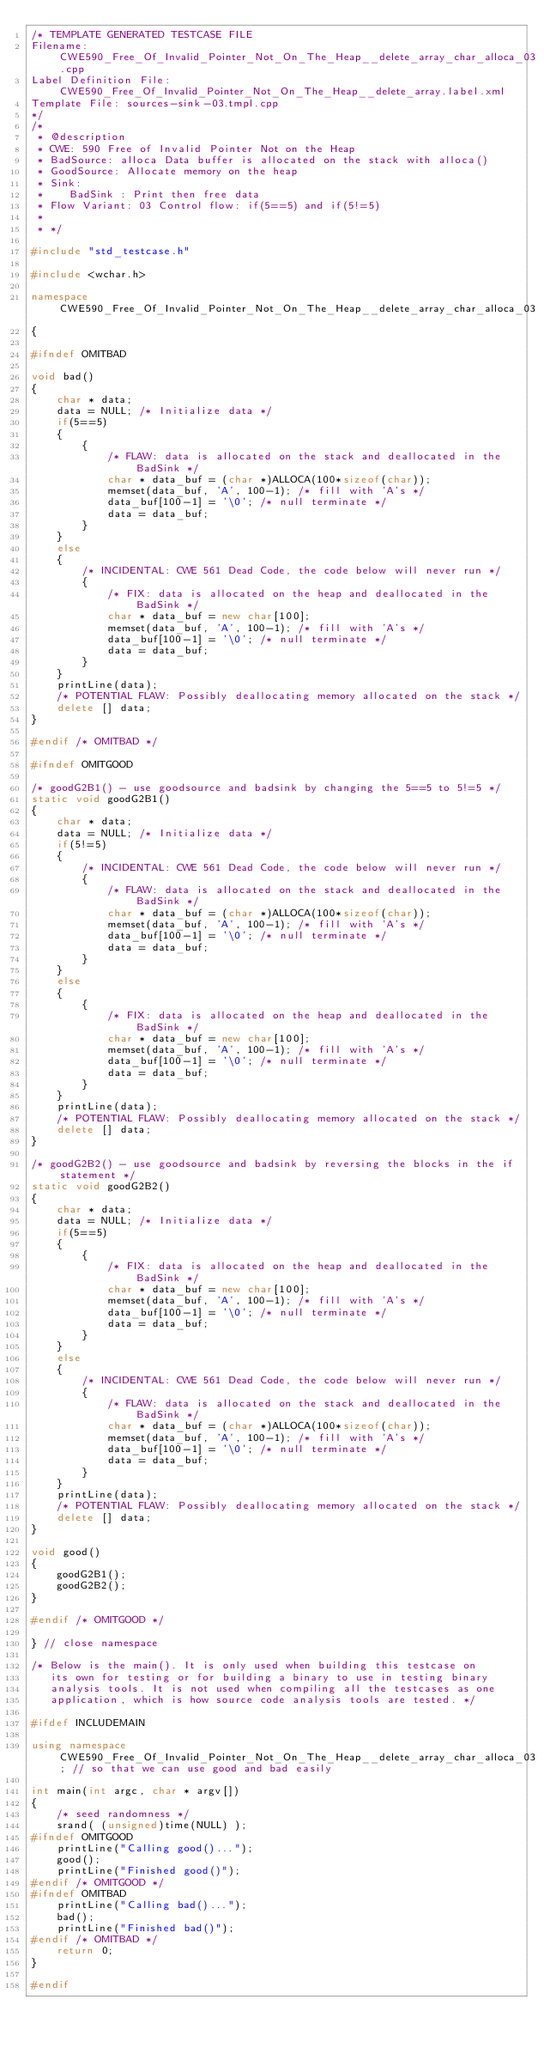Convert code to text. <code><loc_0><loc_0><loc_500><loc_500><_C++_>/* TEMPLATE GENERATED TESTCASE FILE
Filename: CWE590_Free_Of_Invalid_Pointer_Not_On_The_Heap__delete_array_char_alloca_03.cpp
Label Definition File: CWE590_Free_Of_Invalid_Pointer_Not_On_The_Heap__delete_array.label.xml
Template File: sources-sink-03.tmpl.cpp
*/
/*
 * @description
 * CWE: 590 Free of Invalid Pointer Not on the Heap
 * BadSource: alloca Data buffer is allocated on the stack with alloca()
 * GoodSource: Allocate memory on the heap
 * Sink:
 *    BadSink : Print then free data
 * Flow Variant: 03 Control flow: if(5==5) and if(5!=5)
 *
 * */

#include "std_testcase.h"

#include <wchar.h>

namespace CWE590_Free_Of_Invalid_Pointer_Not_On_The_Heap__delete_array_char_alloca_03
{

#ifndef OMITBAD

void bad()
{
    char * data;
    data = NULL; /* Initialize data */
    if(5==5)
    {
        {
            /* FLAW: data is allocated on the stack and deallocated in the BadSink */
            char * data_buf = (char *)ALLOCA(100*sizeof(char));
            memset(data_buf, 'A', 100-1); /* fill with 'A's */
            data_buf[100-1] = '\0'; /* null terminate */
            data = data_buf;
        }
    }
    else
    {
        /* INCIDENTAL: CWE 561 Dead Code, the code below will never run */
        {
            /* FIX: data is allocated on the heap and deallocated in the BadSink */
            char * data_buf = new char[100];
            memset(data_buf, 'A', 100-1); /* fill with 'A's */
            data_buf[100-1] = '\0'; /* null terminate */
            data = data_buf;
        }
    }
    printLine(data);
    /* POTENTIAL FLAW: Possibly deallocating memory allocated on the stack */
    delete [] data;
}

#endif /* OMITBAD */

#ifndef OMITGOOD

/* goodG2B1() - use goodsource and badsink by changing the 5==5 to 5!=5 */
static void goodG2B1()
{
    char * data;
    data = NULL; /* Initialize data */
    if(5!=5)
    {
        /* INCIDENTAL: CWE 561 Dead Code, the code below will never run */
        {
            /* FLAW: data is allocated on the stack and deallocated in the BadSink */
            char * data_buf = (char *)ALLOCA(100*sizeof(char));
            memset(data_buf, 'A', 100-1); /* fill with 'A's */
            data_buf[100-1] = '\0'; /* null terminate */
            data = data_buf;
        }
    }
    else
    {
        {
            /* FIX: data is allocated on the heap and deallocated in the BadSink */
            char * data_buf = new char[100];
            memset(data_buf, 'A', 100-1); /* fill with 'A's */
            data_buf[100-1] = '\0'; /* null terminate */
            data = data_buf;
        }
    }
    printLine(data);
    /* POTENTIAL FLAW: Possibly deallocating memory allocated on the stack */
    delete [] data;
}

/* goodG2B2() - use goodsource and badsink by reversing the blocks in the if statement */
static void goodG2B2()
{
    char * data;
    data = NULL; /* Initialize data */
    if(5==5)
    {
        {
            /* FIX: data is allocated on the heap and deallocated in the BadSink */
            char * data_buf = new char[100];
            memset(data_buf, 'A', 100-1); /* fill with 'A's */
            data_buf[100-1] = '\0'; /* null terminate */
            data = data_buf;
        }
    }
    else
    {
        /* INCIDENTAL: CWE 561 Dead Code, the code below will never run */
        {
            /* FLAW: data is allocated on the stack and deallocated in the BadSink */
            char * data_buf = (char *)ALLOCA(100*sizeof(char));
            memset(data_buf, 'A', 100-1); /* fill with 'A's */
            data_buf[100-1] = '\0'; /* null terminate */
            data = data_buf;
        }
    }
    printLine(data);
    /* POTENTIAL FLAW: Possibly deallocating memory allocated on the stack */
    delete [] data;
}

void good()
{
    goodG2B1();
    goodG2B2();
}

#endif /* OMITGOOD */

} // close namespace

/* Below is the main(). It is only used when building this testcase on
   its own for testing or for building a binary to use in testing binary
   analysis tools. It is not used when compiling all the testcases as one
   application, which is how source code analysis tools are tested. */

#ifdef INCLUDEMAIN

using namespace CWE590_Free_Of_Invalid_Pointer_Not_On_The_Heap__delete_array_char_alloca_03; // so that we can use good and bad easily

int main(int argc, char * argv[])
{
    /* seed randomness */
    srand( (unsigned)time(NULL) );
#ifndef OMITGOOD
    printLine("Calling good()...");
    good();
    printLine("Finished good()");
#endif /* OMITGOOD */
#ifndef OMITBAD
    printLine("Calling bad()...");
    bad();
    printLine("Finished bad()");
#endif /* OMITBAD */
    return 0;
}

#endif
</code> 